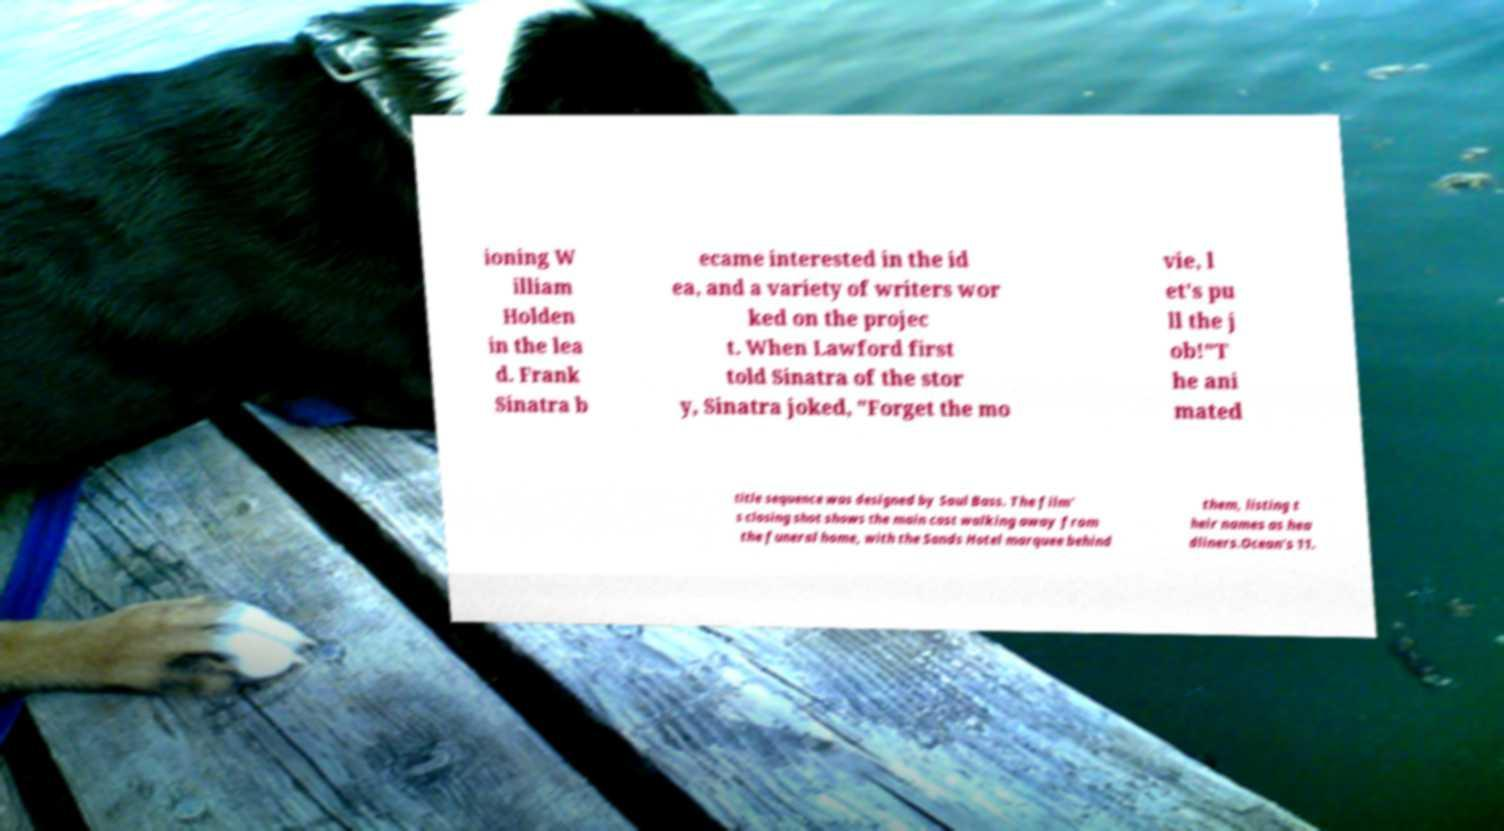I need the written content from this picture converted into text. Can you do that? ioning W illiam Holden in the lea d. Frank Sinatra b ecame interested in the id ea, and a variety of writers wor ked on the projec t. When Lawford first told Sinatra of the stor y, Sinatra joked, "Forget the mo vie, l et's pu ll the j ob!"T he ani mated title sequence was designed by Saul Bass. The film' s closing shot shows the main cast walking away from the funeral home, with the Sands Hotel marquee behind them, listing t heir names as hea dliners.Ocean's 11. 